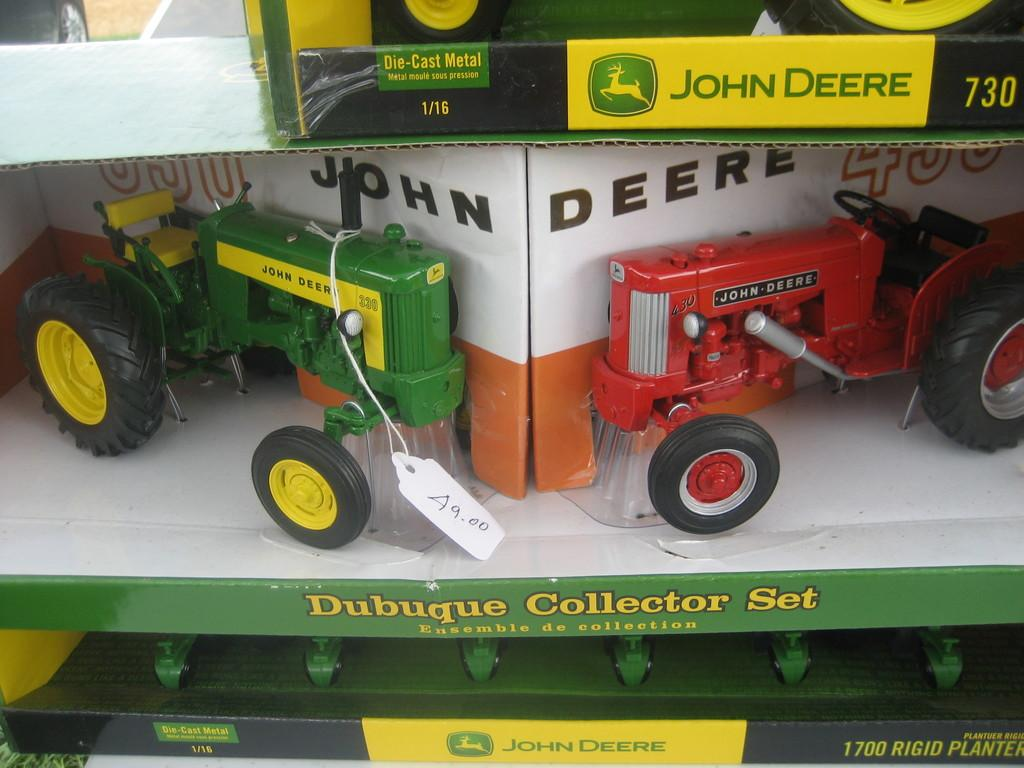What type of toys can be seen in the image? There are toy tractors in the image. Are there any other types of toys present? Yes, there are other toys in the image. How are the toys stored or organized in the image? The toys are in boxes. Can you identify any additional information about the toys or their presentation? There is a price tag with a thread in the image. What expertise does the cow have in the image? There is no cow present in the image, so it is not possible to determine any expertise it might have. 